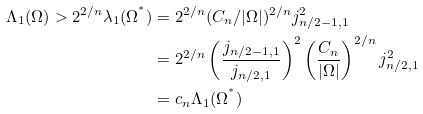Convert formula to latex. <formula><loc_0><loc_0><loc_500><loc_500>\Lambda _ { 1 } ( \Omega ) > 2 ^ { 2 / n } \lambda _ { 1 } ( \Omega ^ { ^ { * } } ) & = 2 ^ { 2 / n } ( C _ { n } / | \Omega | ) ^ { 2 / n } j _ { n / 2 - 1 , 1 } ^ { 2 } \\ & = 2 ^ { 2 / n } \left ( \frac { j _ { n / 2 - 1 , 1 } } { j _ { n / 2 , 1 } } \right ) ^ { 2 } \left ( \frac { C _ { n } } { | \Omega | } \right ) ^ { 2 / n } j _ { n / 2 , 1 } ^ { 2 } \\ & = c _ { n } \Lambda _ { 1 } ( \Omega ^ { ^ { * } } )</formula> 